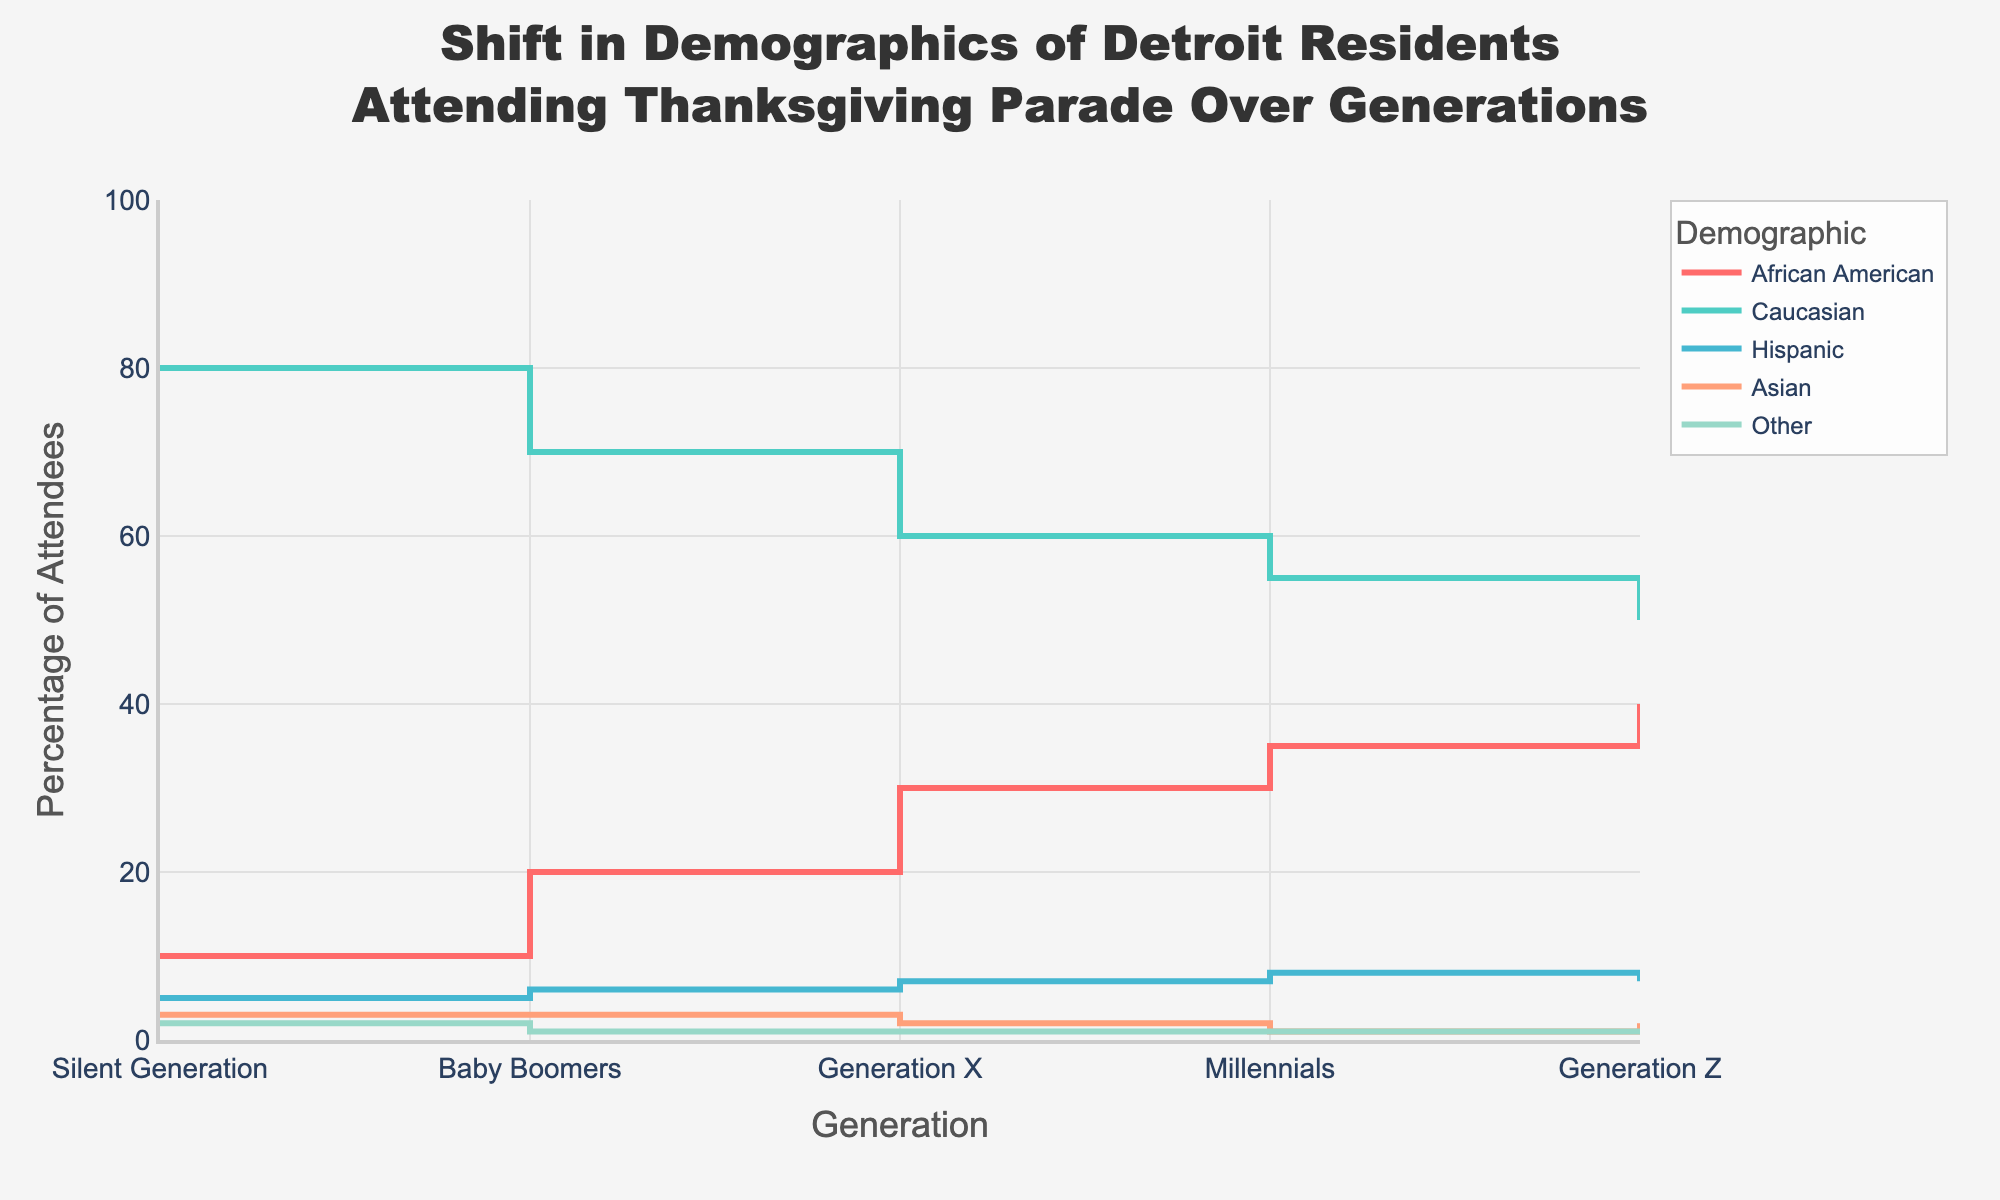Which generation shows the highest percentage of African American attendees? By looking at the plot, the line representing African American attendees (in red) shows the highest point at Generation Z.
Answer: Generation Z What is the percentage difference in Caucasian attendees between the Silent Generation and Generation Z? The plot shows 80% for Caucasian attendees in the Silent Generation and 50% in Generation Z. The difference is 80% - 50% = 30%.
Answer: 30% Which demographic shows a consistent increase in attendance percentages across all generations? The red line (African American attendees) consistently rises across all generations without any drop.
Answer: African American attendees For which demographic did the percentage of attendees decrease between Baby Boomers and Millennials? The cyan line (Caucasian attendees) shows a decline from Baby Boomers (70%) to Millennials (55%).
Answer: Caucasian attendees What is the general trend for Hispanic attendees over the generations? The brown line (Hispanic attendees) indicates a general upward trend from 5% in the Silent Generation to 8% in Millennials, then a slight drop to 7% in Generation Z.
Answer: General increase with slight drop in Gen Z Which demographic remained relatively stable in terms of percentage over the generations? The light blue line (Asian attendees) mostly remained around 2-3% across generations without significant changes.
Answer: Asian attendees In which generation did the "Other" demographic have the least percentage of attendees? The "Other" demographic, represented by a green line, shows the least percentage during the Baby Boomer generation at 1%.
Answer: Baby Boomers What can we infer about the demographic shift among Caucasian attendees from Silent Generation to Generation Z? The line for Caucasian attendees (in green) shows a steep decline from 80% in the Silent Generation to 50% in Generation Z, indicating a significant demographic shift.
Answer: Significant decline Compare the percentage of Hispanic attendees in Silent Generation and Generation Z. The brown line representing Hispanic attendees shows 5% in the Silent Generation and 7% in Generation Z, indicating an increase.
Answer: 7% in Generation Z, 5% in Silent Generation 